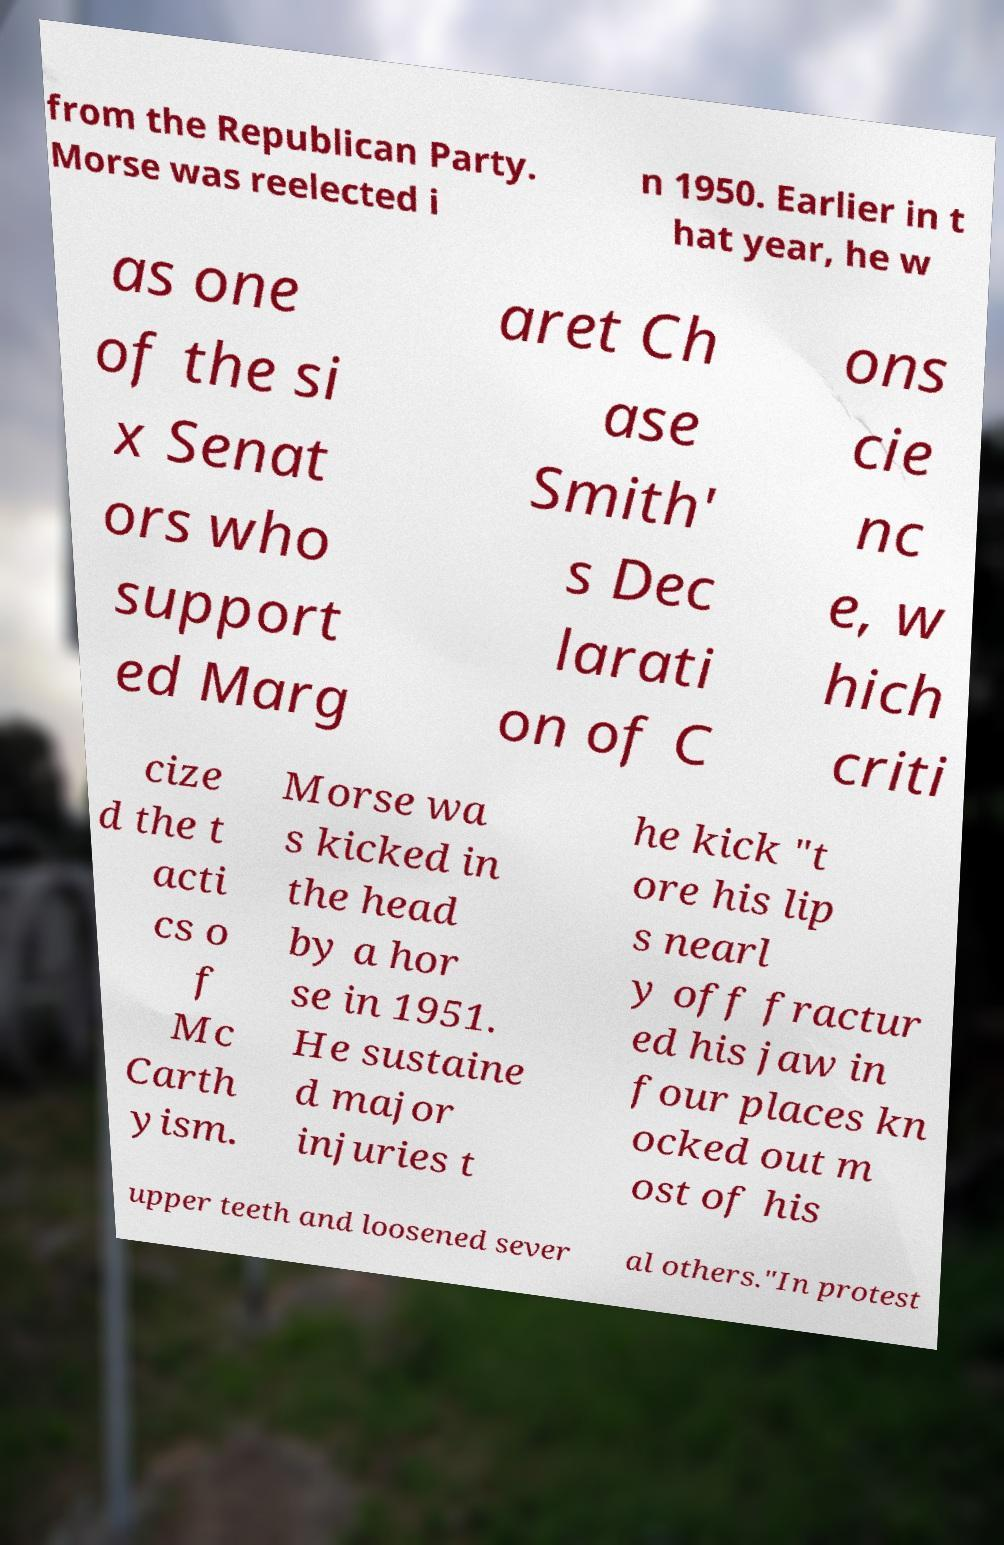Please identify and transcribe the text found in this image. from the Republican Party. Morse was reelected i n 1950. Earlier in t hat year, he w as one of the si x Senat ors who support ed Marg aret Ch ase Smith' s Dec larati on of C ons cie nc e, w hich criti cize d the t acti cs o f Mc Carth yism. Morse wa s kicked in the head by a hor se in 1951. He sustaine d major injuries t he kick "t ore his lip s nearl y off fractur ed his jaw in four places kn ocked out m ost of his upper teeth and loosened sever al others."In protest 